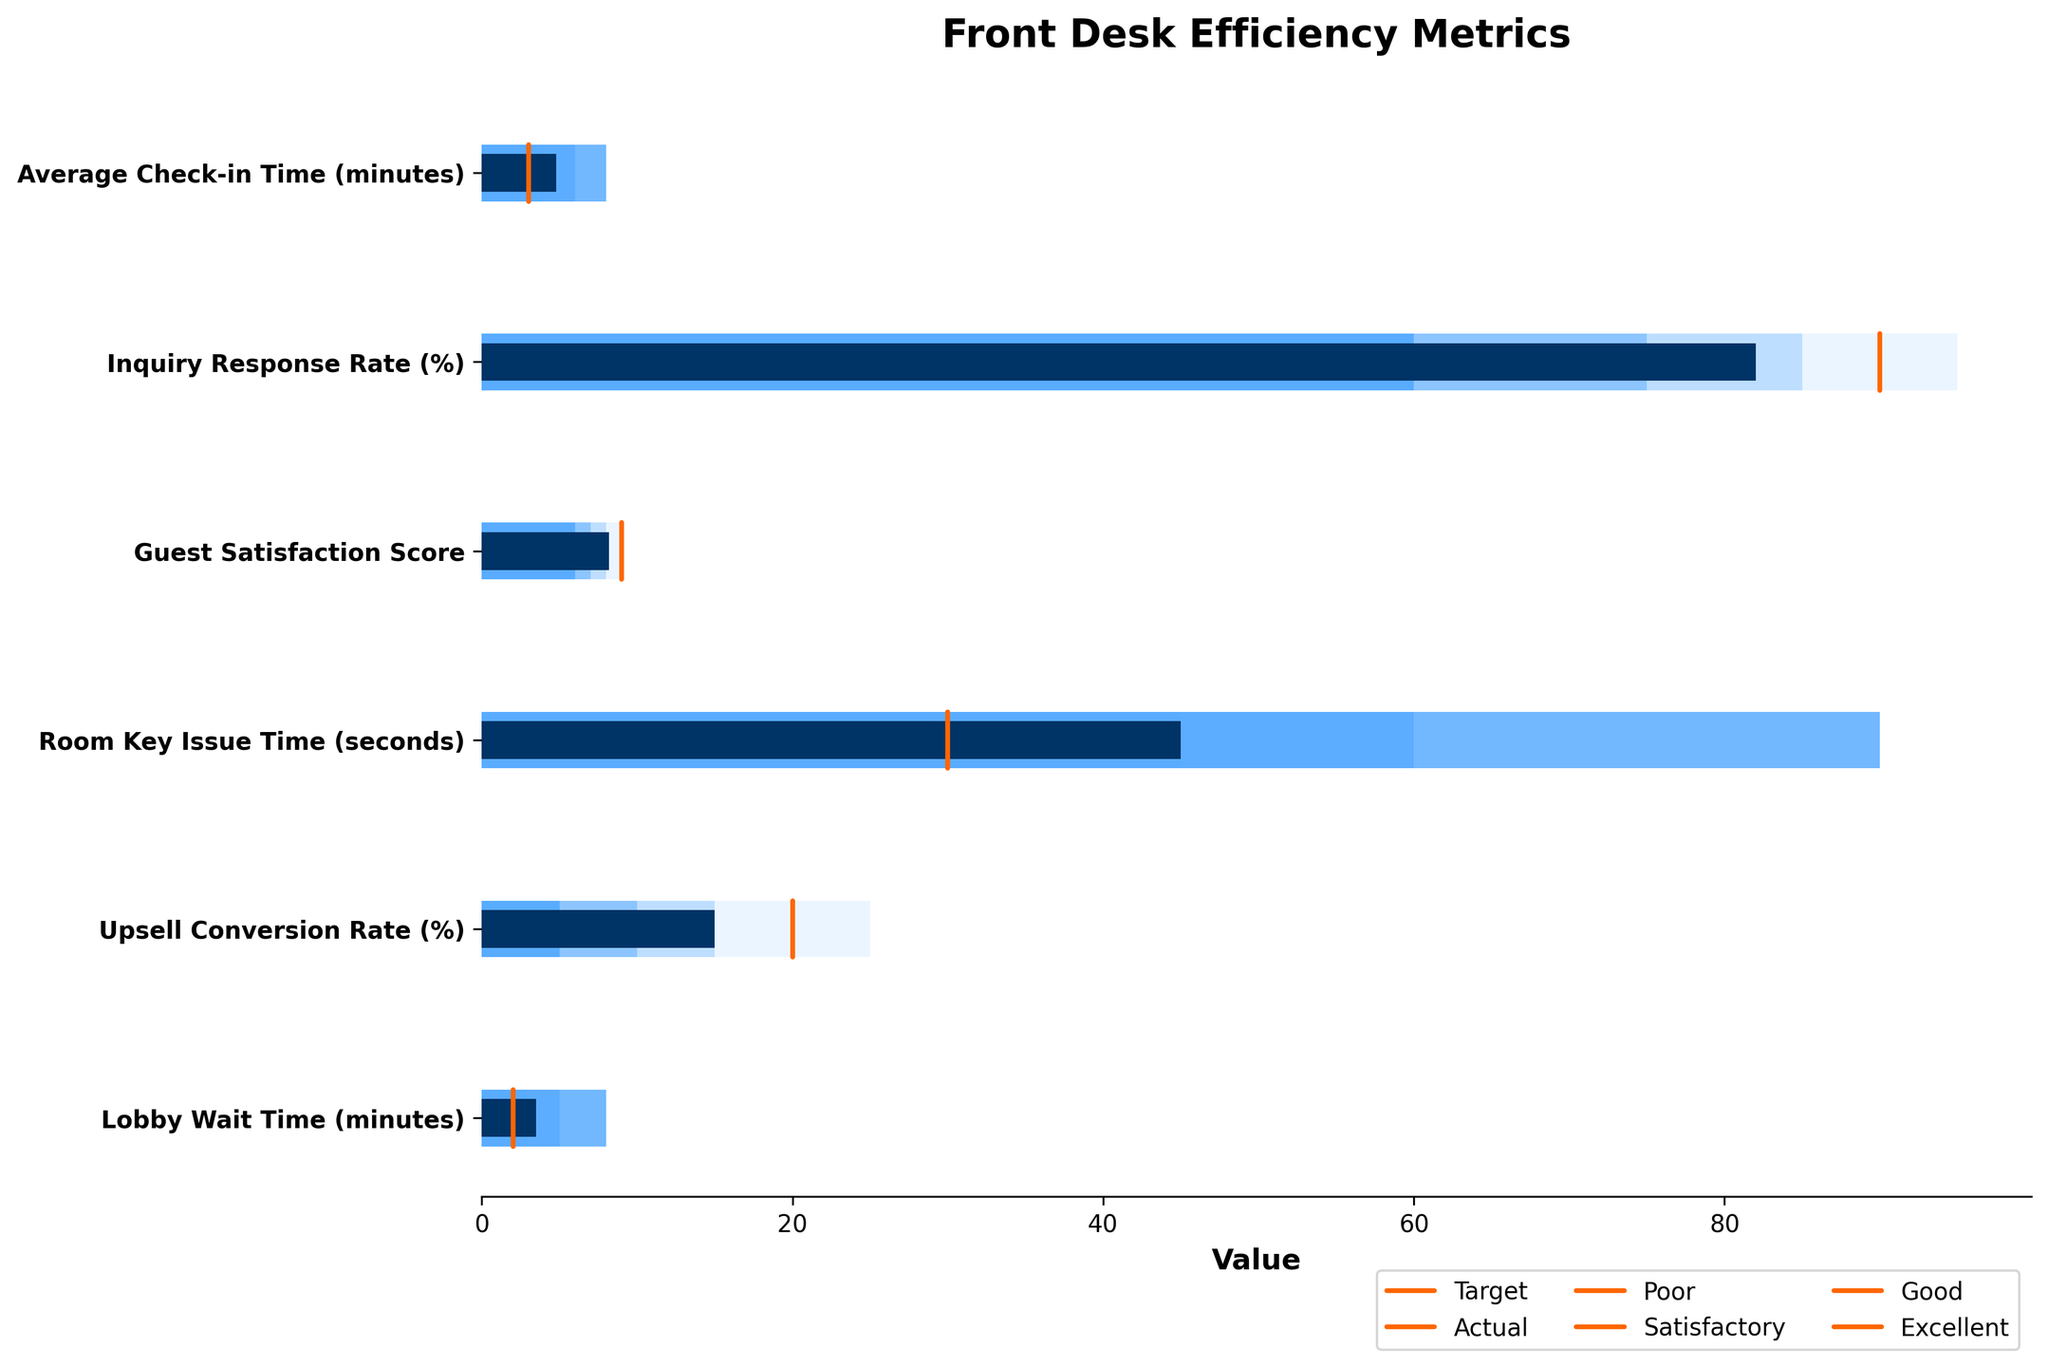What is the title of the figure? The title of the figure is given at the top of the chart.
Answer: Front Desk Efficiency Metrics What metric has the worst performance compared to its target? The metric with the largest difference between the actual value and the target value indicates the worst performance. The Inquiry Response Rate has an actual value of 82% and a target of 90%, making it the worst performer.
Answer: Inquiry Response Rate How much higher than the target is the Room Key Issue Time? The target for Room Key Issue Time is 30 seconds, and the actual value is 45 seconds. The difference between them is 45 - 30 = 15 seconds.
Answer: 15 seconds Which metrics meet or exceed their targets? Look for metrics where the actual value is less than or equal to the target. Guest Satisfaction Score (8.2 ≥ 9), Room Key Issue Time (45 ≤ 30), and Upsell Conversion Rate (15 ≤ 20) do not satisfy this condition. Therefore, none meet or exceed their targets.
Answer: None What is the range of values considered 'Good' for the Lobby Wait Time? The range labeled 'Good' for Lobby Wait Time is indicated on the chart. It spans from 3 minutes to 1 minute.
Answer: 3-1 minutes Which metric is closest to its 'Excellent' range? Check for the metric whose actual value is closest to the boundary of its 'Excellent' range. The Actual values closest to 'Excellent' are Guest Satisfaction Score (9), Room Key Issue Time (30), and Lobby Wait Time (1 minute). Guest Satisfaction Score (8.2) is the closest at 0.8 away from 9.
Answer: Guest Satisfaction Score How many metrics are considered 'Poor'? The 'Poor' category includes metrics whose actual value is within the range indicated for 'Poor'. These ranges are indicated in darker shades on the bullet chart. There are no metrics whose actual values fall within the 'Poor' range.
Answer: None Which metrics are in the 'Satisfactory' range? Metrics are in the 'Satisfactory' range if their actual values fall within the 'Satisfactory' band. Average Check-in Time (4.8 minutes), Inquiry Response Rate (82%), and Lobby Wait Time (3.5 minutes) all have actual values that fall within their corresponding 'Satisfactory' ranges.
Answer: Average Check-in Time, Inquiry Response Rate, Lobby Wait Time What is the percentage difference between the actual value and the target for the Upsell Conversion Rate? The target is 20%, and the actual value is 15%. The percentage difference can be calculated as ((Target - Actual) / Target) * 100. So, [(20 - 15) / 20] * 100 = 25%.
Answer: 25% In which color are 'Poor' ranges indicated in the chart? The 'Poor' ranges are indicated in the color with the darkest shade among the horizontal bars.
Answer: Dark Blue 